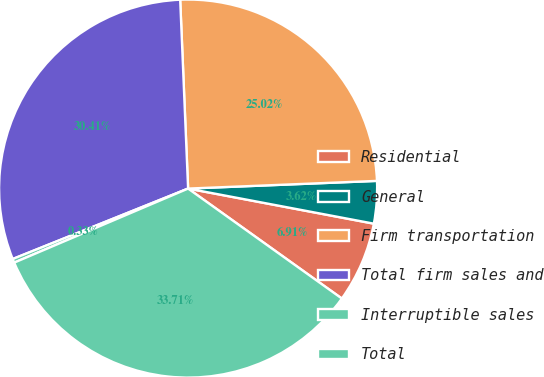<chart> <loc_0><loc_0><loc_500><loc_500><pie_chart><fcel>Residential<fcel>General<fcel>Firm transportation<fcel>Total firm sales and<fcel>Interruptible sales<fcel>Total<nl><fcel>6.91%<fcel>3.62%<fcel>25.02%<fcel>30.41%<fcel>0.33%<fcel>33.71%<nl></chart> 